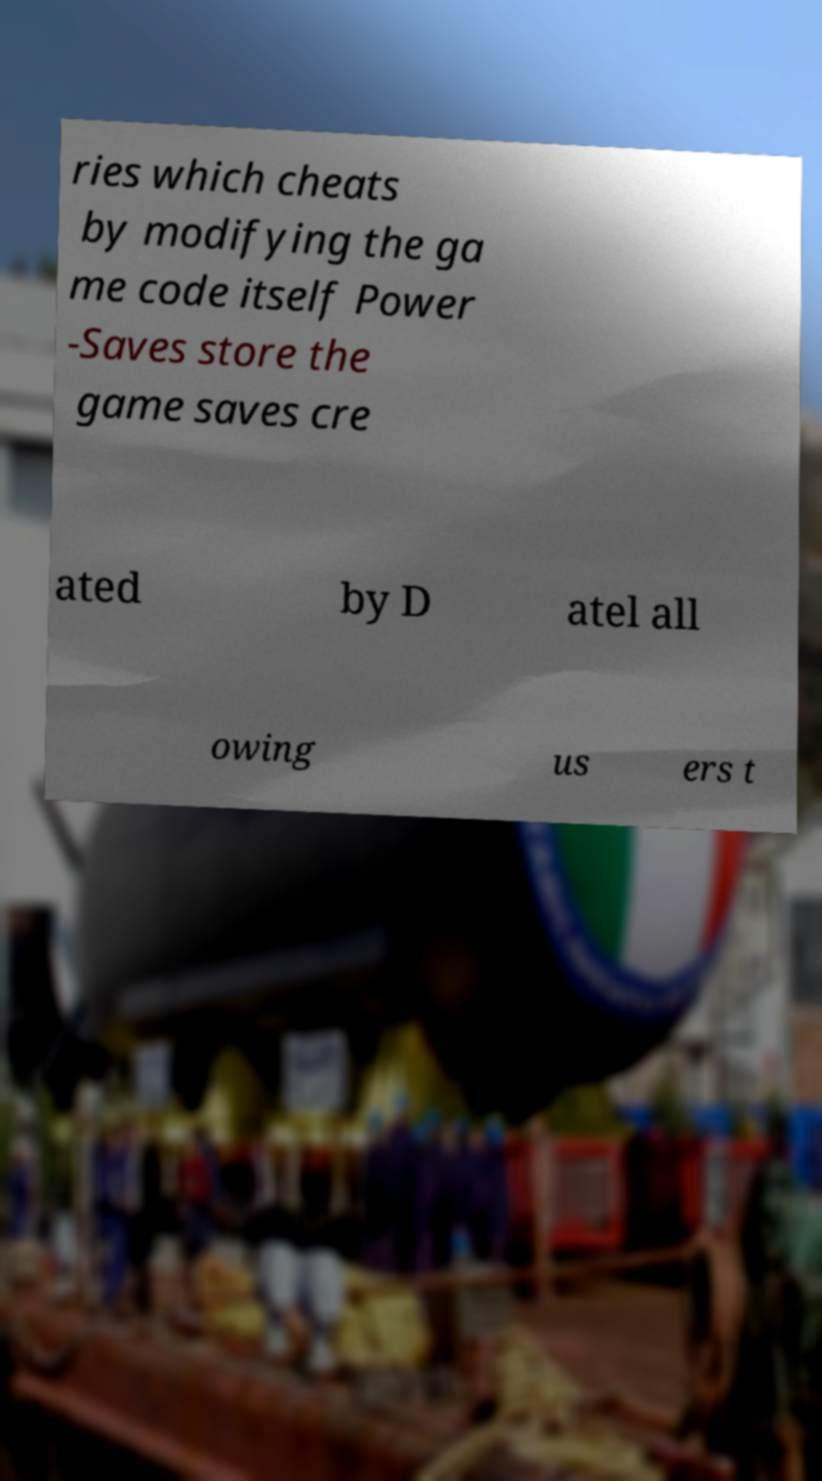Could you extract and type out the text from this image? ries which cheats by modifying the ga me code itself Power -Saves store the game saves cre ated by D atel all owing us ers t 